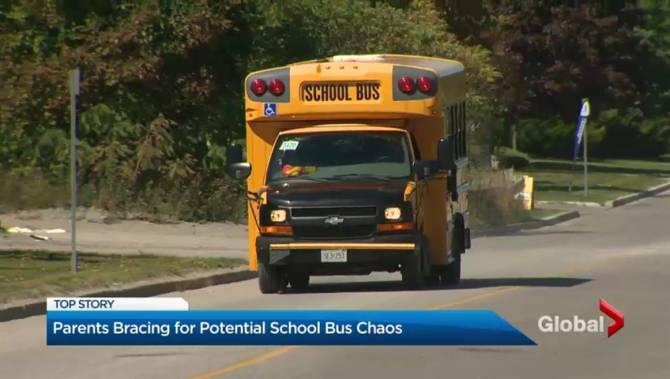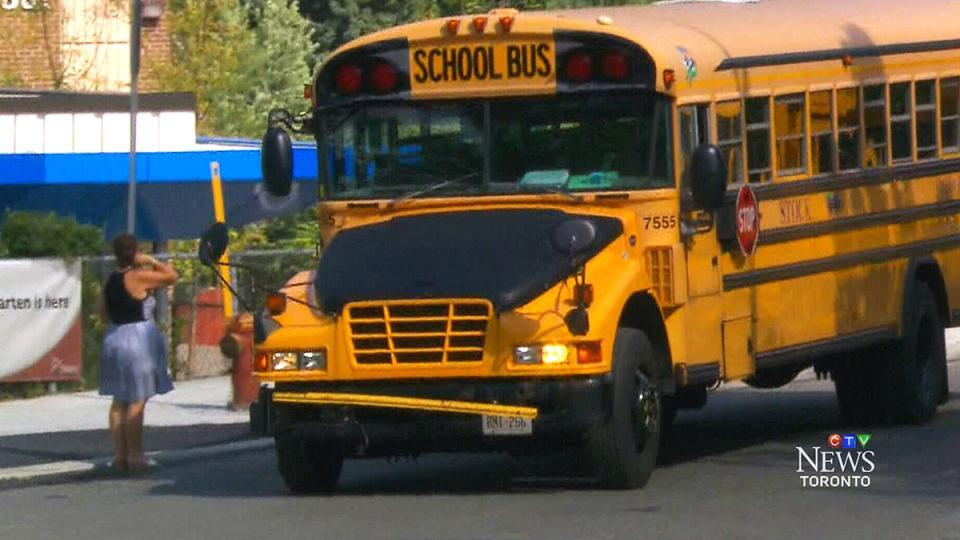The first image is the image on the left, the second image is the image on the right. Considering the images on both sides, is "In the left image, a person is in the open doorway of a bus that faces rightward, with at least one foot on the first step." valid? Answer yes or no. No. The first image is the image on the left, the second image is the image on the right. For the images shown, is this caption "the left and right image contains the same number of buses." true? Answer yes or no. Yes. 